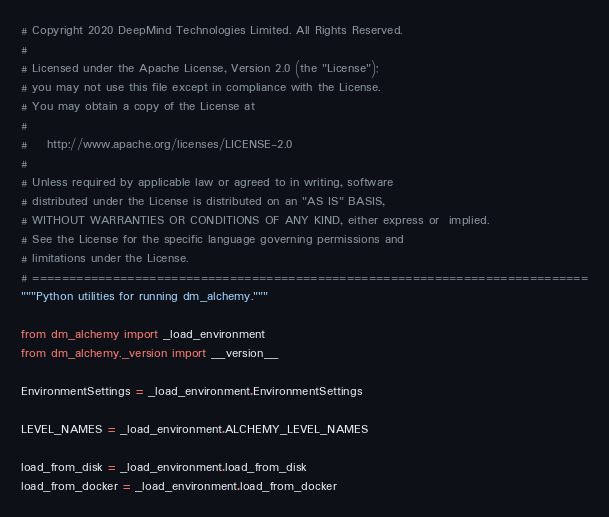Convert code to text. <code><loc_0><loc_0><loc_500><loc_500><_Python_># Copyright 2020 DeepMind Technologies Limited. All Rights Reserved.
#
# Licensed under the Apache License, Version 2.0 (the "License");
# you may not use this file except in compliance with the License.
# You may obtain a copy of the License at
#
#    http://www.apache.org/licenses/LICENSE-2.0
#
# Unless required by applicable law or agreed to in writing, software
# distributed under the License is distributed on an "AS IS" BASIS,
# WITHOUT WARRANTIES OR CONDITIONS OF ANY KIND, either express or  implied.
# See the License for the specific language governing permissions and
# limitations under the License.
# ============================================================================
"""Python utilities for running dm_alchemy."""

from dm_alchemy import _load_environment
from dm_alchemy._version import __version__

EnvironmentSettings = _load_environment.EnvironmentSettings

LEVEL_NAMES = _load_environment.ALCHEMY_LEVEL_NAMES

load_from_disk = _load_environment.load_from_disk
load_from_docker = _load_environment.load_from_docker
</code> 